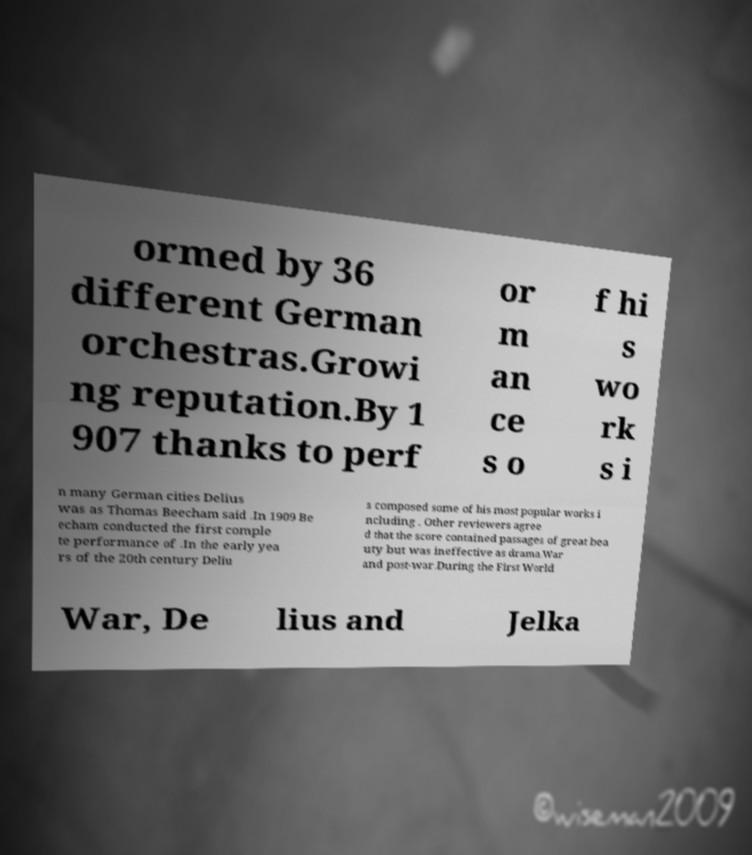Please read and relay the text visible in this image. What does it say? ormed by 36 different German orchestras.Growi ng reputation.By 1 907 thanks to perf or m an ce s o f hi s wo rk s i n many German cities Delius was as Thomas Beecham said .In 1909 Be echam conducted the first comple te performance of .In the early yea rs of the 20th century Deliu s composed some of his most popular works i ncluding . Other reviewers agree d that the score contained passages of great bea uty but was ineffective as drama.War and post-war.During the First World War, De lius and Jelka 